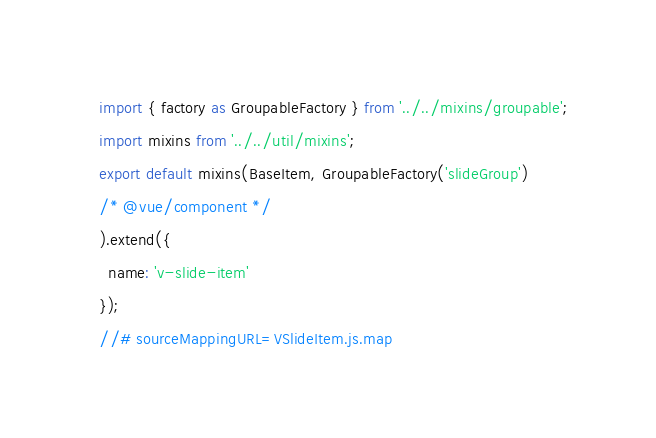<code> <loc_0><loc_0><loc_500><loc_500><_JavaScript_>
import { factory as GroupableFactory } from '../../mixins/groupable';
import mixins from '../../util/mixins';
export default mixins(BaseItem, GroupableFactory('slideGroup')
/* @vue/component */
).extend({
  name: 'v-slide-item'
});
//# sourceMappingURL=VSlideItem.js.map</code> 